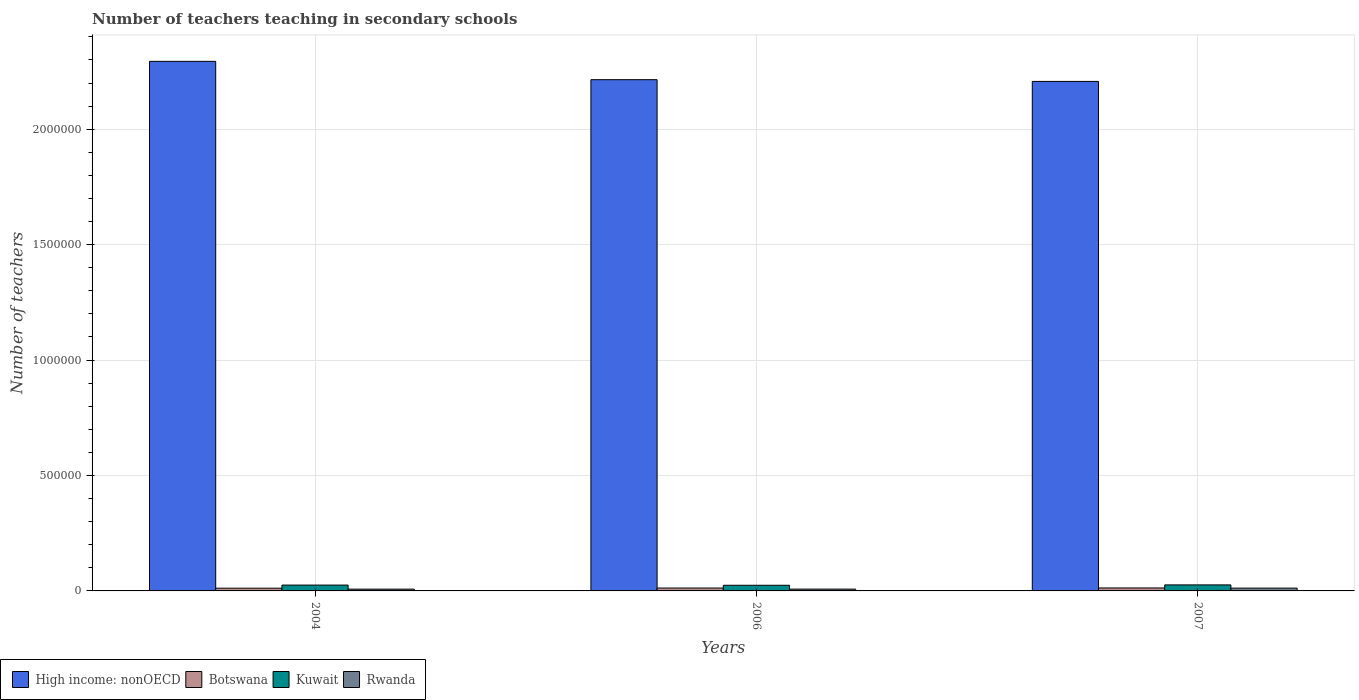How many different coloured bars are there?
Offer a very short reply. 4. How many groups of bars are there?
Ensure brevity in your answer.  3. Are the number of bars on each tick of the X-axis equal?
Offer a terse response. Yes. What is the label of the 2nd group of bars from the left?
Provide a succinct answer. 2006. What is the number of teachers teaching in secondary schools in Kuwait in 2006?
Give a very brief answer. 2.44e+04. Across all years, what is the maximum number of teachers teaching in secondary schools in Kuwait?
Give a very brief answer. 2.61e+04. Across all years, what is the minimum number of teachers teaching in secondary schools in High income: nonOECD?
Keep it short and to the point. 2.21e+06. What is the total number of teachers teaching in secondary schools in Rwanda in the graph?
Provide a succinct answer. 2.77e+04. What is the difference between the number of teachers teaching in secondary schools in High income: nonOECD in 2004 and that in 2007?
Provide a short and direct response. 8.69e+04. What is the difference between the number of teachers teaching in secondary schools in High income: nonOECD in 2006 and the number of teachers teaching in secondary schools in Botswana in 2004?
Provide a short and direct response. 2.20e+06. What is the average number of teachers teaching in secondary schools in High income: nonOECD per year?
Offer a very short reply. 2.24e+06. In the year 2007, what is the difference between the number of teachers teaching in secondary schools in Rwanda and number of teachers teaching in secondary schools in Kuwait?
Offer a terse response. -1.40e+04. In how many years, is the number of teachers teaching in secondary schools in Botswana greater than 400000?
Provide a short and direct response. 0. What is the ratio of the number of teachers teaching in secondary schools in Botswana in 2004 to that in 2007?
Offer a very short reply. 0.93. Is the number of teachers teaching in secondary schools in Rwanda in 2006 less than that in 2007?
Your response must be concise. Yes. Is the difference between the number of teachers teaching in secondary schools in Rwanda in 2004 and 2007 greater than the difference between the number of teachers teaching in secondary schools in Kuwait in 2004 and 2007?
Keep it short and to the point. No. What is the difference between the highest and the second highest number of teachers teaching in secondary schools in Botswana?
Make the answer very short. 317. What is the difference between the highest and the lowest number of teachers teaching in secondary schools in Kuwait?
Provide a succinct answer. 1658. Is it the case that in every year, the sum of the number of teachers teaching in secondary schools in High income: nonOECD and number of teachers teaching in secondary schools in Kuwait is greater than the sum of number of teachers teaching in secondary schools in Botswana and number of teachers teaching in secondary schools in Rwanda?
Give a very brief answer. Yes. What does the 3rd bar from the left in 2007 represents?
Your answer should be very brief. Kuwait. What does the 2nd bar from the right in 2004 represents?
Provide a short and direct response. Kuwait. How many bars are there?
Ensure brevity in your answer.  12. Are all the bars in the graph horizontal?
Provide a succinct answer. No. How many years are there in the graph?
Your response must be concise. 3. What is the difference between two consecutive major ticks on the Y-axis?
Give a very brief answer. 5.00e+05. Does the graph contain any zero values?
Your answer should be very brief. No. How many legend labels are there?
Provide a short and direct response. 4. What is the title of the graph?
Offer a very short reply. Number of teachers teaching in secondary schools. Does "St. Vincent and the Grenadines" appear as one of the legend labels in the graph?
Your answer should be very brief. No. What is the label or title of the X-axis?
Provide a succinct answer. Years. What is the label or title of the Y-axis?
Ensure brevity in your answer.  Number of teachers. What is the Number of teachers of High income: nonOECD in 2004?
Offer a very short reply. 2.29e+06. What is the Number of teachers of Botswana in 2004?
Provide a succinct answer. 1.18e+04. What is the Number of teachers in Kuwait in 2004?
Offer a very short reply. 2.53e+04. What is the Number of teachers in Rwanda in 2004?
Ensure brevity in your answer.  7750. What is the Number of teachers in High income: nonOECD in 2006?
Your answer should be compact. 2.21e+06. What is the Number of teachers of Botswana in 2006?
Make the answer very short. 1.25e+04. What is the Number of teachers in Kuwait in 2006?
Provide a succinct answer. 2.44e+04. What is the Number of teachers of Rwanda in 2006?
Offer a very short reply. 7818. What is the Number of teachers of High income: nonOECD in 2007?
Your answer should be very brief. 2.21e+06. What is the Number of teachers in Botswana in 2007?
Your answer should be very brief. 1.28e+04. What is the Number of teachers of Kuwait in 2007?
Your response must be concise. 2.61e+04. What is the Number of teachers in Rwanda in 2007?
Offer a terse response. 1.21e+04. Across all years, what is the maximum Number of teachers in High income: nonOECD?
Offer a very short reply. 2.29e+06. Across all years, what is the maximum Number of teachers of Botswana?
Keep it short and to the point. 1.28e+04. Across all years, what is the maximum Number of teachers in Kuwait?
Give a very brief answer. 2.61e+04. Across all years, what is the maximum Number of teachers in Rwanda?
Your answer should be very brief. 1.21e+04. Across all years, what is the minimum Number of teachers of High income: nonOECD?
Provide a short and direct response. 2.21e+06. Across all years, what is the minimum Number of teachers of Botswana?
Offer a very short reply. 1.18e+04. Across all years, what is the minimum Number of teachers in Kuwait?
Ensure brevity in your answer.  2.44e+04. Across all years, what is the minimum Number of teachers in Rwanda?
Your response must be concise. 7750. What is the total Number of teachers in High income: nonOECD in the graph?
Offer a terse response. 6.72e+06. What is the total Number of teachers in Botswana in the graph?
Give a very brief answer. 3.71e+04. What is the total Number of teachers in Kuwait in the graph?
Ensure brevity in your answer.  7.58e+04. What is the total Number of teachers of Rwanda in the graph?
Give a very brief answer. 2.77e+04. What is the difference between the Number of teachers of High income: nonOECD in 2004 and that in 2006?
Your answer should be compact. 7.94e+04. What is the difference between the Number of teachers in Botswana in 2004 and that in 2006?
Offer a very short reply. -636. What is the difference between the Number of teachers of Kuwait in 2004 and that in 2006?
Offer a very short reply. 848. What is the difference between the Number of teachers in Rwanda in 2004 and that in 2006?
Offer a terse response. -68. What is the difference between the Number of teachers in High income: nonOECD in 2004 and that in 2007?
Keep it short and to the point. 8.69e+04. What is the difference between the Number of teachers of Botswana in 2004 and that in 2007?
Keep it short and to the point. -953. What is the difference between the Number of teachers in Kuwait in 2004 and that in 2007?
Give a very brief answer. -810. What is the difference between the Number of teachers in Rwanda in 2004 and that in 2007?
Your answer should be compact. -4353. What is the difference between the Number of teachers in High income: nonOECD in 2006 and that in 2007?
Provide a short and direct response. 7549.5. What is the difference between the Number of teachers of Botswana in 2006 and that in 2007?
Your answer should be very brief. -317. What is the difference between the Number of teachers in Kuwait in 2006 and that in 2007?
Make the answer very short. -1658. What is the difference between the Number of teachers in Rwanda in 2006 and that in 2007?
Ensure brevity in your answer.  -4285. What is the difference between the Number of teachers of High income: nonOECD in 2004 and the Number of teachers of Botswana in 2006?
Give a very brief answer. 2.28e+06. What is the difference between the Number of teachers in High income: nonOECD in 2004 and the Number of teachers in Kuwait in 2006?
Your response must be concise. 2.27e+06. What is the difference between the Number of teachers in High income: nonOECD in 2004 and the Number of teachers in Rwanda in 2006?
Offer a very short reply. 2.29e+06. What is the difference between the Number of teachers of Botswana in 2004 and the Number of teachers of Kuwait in 2006?
Keep it short and to the point. -1.26e+04. What is the difference between the Number of teachers of Botswana in 2004 and the Number of teachers of Rwanda in 2006?
Your answer should be very brief. 4027. What is the difference between the Number of teachers of Kuwait in 2004 and the Number of teachers of Rwanda in 2006?
Keep it short and to the point. 1.75e+04. What is the difference between the Number of teachers in High income: nonOECD in 2004 and the Number of teachers in Botswana in 2007?
Your answer should be very brief. 2.28e+06. What is the difference between the Number of teachers of High income: nonOECD in 2004 and the Number of teachers of Kuwait in 2007?
Ensure brevity in your answer.  2.27e+06. What is the difference between the Number of teachers in High income: nonOECD in 2004 and the Number of teachers in Rwanda in 2007?
Provide a short and direct response. 2.28e+06. What is the difference between the Number of teachers in Botswana in 2004 and the Number of teachers in Kuwait in 2007?
Your answer should be compact. -1.43e+04. What is the difference between the Number of teachers in Botswana in 2004 and the Number of teachers in Rwanda in 2007?
Ensure brevity in your answer.  -258. What is the difference between the Number of teachers in Kuwait in 2004 and the Number of teachers in Rwanda in 2007?
Your answer should be compact. 1.32e+04. What is the difference between the Number of teachers of High income: nonOECD in 2006 and the Number of teachers of Botswana in 2007?
Make the answer very short. 2.20e+06. What is the difference between the Number of teachers in High income: nonOECD in 2006 and the Number of teachers in Kuwait in 2007?
Make the answer very short. 2.19e+06. What is the difference between the Number of teachers in High income: nonOECD in 2006 and the Number of teachers in Rwanda in 2007?
Make the answer very short. 2.20e+06. What is the difference between the Number of teachers in Botswana in 2006 and the Number of teachers in Kuwait in 2007?
Ensure brevity in your answer.  -1.36e+04. What is the difference between the Number of teachers in Botswana in 2006 and the Number of teachers in Rwanda in 2007?
Your answer should be compact. 378. What is the difference between the Number of teachers in Kuwait in 2006 and the Number of teachers in Rwanda in 2007?
Your response must be concise. 1.23e+04. What is the average Number of teachers in High income: nonOECD per year?
Provide a succinct answer. 2.24e+06. What is the average Number of teachers in Botswana per year?
Keep it short and to the point. 1.24e+04. What is the average Number of teachers of Kuwait per year?
Keep it short and to the point. 2.53e+04. What is the average Number of teachers in Rwanda per year?
Offer a very short reply. 9223.67. In the year 2004, what is the difference between the Number of teachers in High income: nonOECD and Number of teachers in Botswana?
Your answer should be compact. 2.28e+06. In the year 2004, what is the difference between the Number of teachers in High income: nonOECD and Number of teachers in Kuwait?
Provide a short and direct response. 2.27e+06. In the year 2004, what is the difference between the Number of teachers in High income: nonOECD and Number of teachers in Rwanda?
Ensure brevity in your answer.  2.29e+06. In the year 2004, what is the difference between the Number of teachers in Botswana and Number of teachers in Kuwait?
Keep it short and to the point. -1.34e+04. In the year 2004, what is the difference between the Number of teachers of Botswana and Number of teachers of Rwanda?
Provide a succinct answer. 4095. In the year 2004, what is the difference between the Number of teachers of Kuwait and Number of teachers of Rwanda?
Your response must be concise. 1.75e+04. In the year 2006, what is the difference between the Number of teachers of High income: nonOECD and Number of teachers of Botswana?
Provide a short and direct response. 2.20e+06. In the year 2006, what is the difference between the Number of teachers in High income: nonOECD and Number of teachers in Kuwait?
Your response must be concise. 2.19e+06. In the year 2006, what is the difference between the Number of teachers in High income: nonOECD and Number of teachers in Rwanda?
Offer a terse response. 2.21e+06. In the year 2006, what is the difference between the Number of teachers in Botswana and Number of teachers in Kuwait?
Ensure brevity in your answer.  -1.20e+04. In the year 2006, what is the difference between the Number of teachers in Botswana and Number of teachers in Rwanda?
Make the answer very short. 4663. In the year 2006, what is the difference between the Number of teachers of Kuwait and Number of teachers of Rwanda?
Provide a succinct answer. 1.66e+04. In the year 2007, what is the difference between the Number of teachers in High income: nonOECD and Number of teachers in Botswana?
Provide a short and direct response. 2.19e+06. In the year 2007, what is the difference between the Number of teachers in High income: nonOECD and Number of teachers in Kuwait?
Your answer should be compact. 2.18e+06. In the year 2007, what is the difference between the Number of teachers of High income: nonOECD and Number of teachers of Rwanda?
Make the answer very short. 2.19e+06. In the year 2007, what is the difference between the Number of teachers in Botswana and Number of teachers in Kuwait?
Your response must be concise. -1.33e+04. In the year 2007, what is the difference between the Number of teachers in Botswana and Number of teachers in Rwanda?
Your answer should be very brief. 695. In the year 2007, what is the difference between the Number of teachers in Kuwait and Number of teachers in Rwanda?
Provide a succinct answer. 1.40e+04. What is the ratio of the Number of teachers in High income: nonOECD in 2004 to that in 2006?
Provide a succinct answer. 1.04. What is the ratio of the Number of teachers of Botswana in 2004 to that in 2006?
Keep it short and to the point. 0.95. What is the ratio of the Number of teachers in Kuwait in 2004 to that in 2006?
Offer a terse response. 1.03. What is the ratio of the Number of teachers of Rwanda in 2004 to that in 2006?
Offer a very short reply. 0.99. What is the ratio of the Number of teachers in High income: nonOECD in 2004 to that in 2007?
Provide a succinct answer. 1.04. What is the ratio of the Number of teachers of Botswana in 2004 to that in 2007?
Give a very brief answer. 0.93. What is the ratio of the Number of teachers of Rwanda in 2004 to that in 2007?
Make the answer very short. 0.64. What is the ratio of the Number of teachers in High income: nonOECD in 2006 to that in 2007?
Give a very brief answer. 1. What is the ratio of the Number of teachers in Botswana in 2006 to that in 2007?
Your answer should be compact. 0.98. What is the ratio of the Number of teachers in Kuwait in 2006 to that in 2007?
Offer a terse response. 0.94. What is the ratio of the Number of teachers of Rwanda in 2006 to that in 2007?
Keep it short and to the point. 0.65. What is the difference between the highest and the second highest Number of teachers of High income: nonOECD?
Keep it short and to the point. 7.94e+04. What is the difference between the highest and the second highest Number of teachers in Botswana?
Your answer should be very brief. 317. What is the difference between the highest and the second highest Number of teachers of Kuwait?
Your answer should be compact. 810. What is the difference between the highest and the second highest Number of teachers in Rwanda?
Your answer should be very brief. 4285. What is the difference between the highest and the lowest Number of teachers in High income: nonOECD?
Give a very brief answer. 8.69e+04. What is the difference between the highest and the lowest Number of teachers of Botswana?
Offer a terse response. 953. What is the difference between the highest and the lowest Number of teachers in Kuwait?
Your answer should be very brief. 1658. What is the difference between the highest and the lowest Number of teachers in Rwanda?
Offer a very short reply. 4353. 